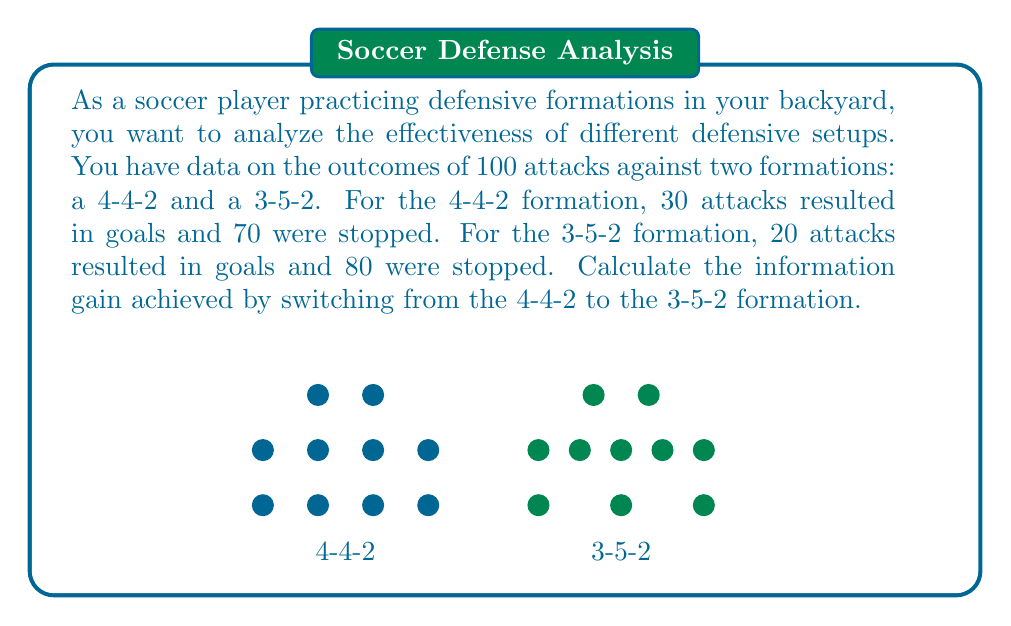Show me your answer to this math problem. To calculate the information gain, we need to compute the entropy before and after the change in formation. Let's go through this step-by-step:

1. Calculate the entropy for the 4-4-2 formation:
   Let $p(goal) = 30/100 = 0.3$ and $p(stopped) = 70/100 = 0.7$
   
   $$H(4-4-2) = -0.3 \log_2(0.3) - 0.7 \log_2(0.7)$$
   $$H(4-4-2) = 0.3 * 1.737 + 0.7 * 0.515 = 0.8821 \text{ bits}$$

2. Calculate the entropy for the 3-5-2 formation:
   Let $p(goal) = 20/100 = 0.2$ and $p(stopped) = 80/100 = 0.8$
   
   $$H(3-5-2) = -0.2 \log_2(0.2) - 0.8 \log_2(0.8)$$
   $$H(3-5-2) = 0.2 * 2.322 + 0.8 * 0.322 = 0.7219 \text{ bits}$$

3. Calculate the information gain:
   Information Gain = Entropy(before) - Entropy(after)
   $$IG = H(4-4-2) - H(3-5-2)$$
   $$IG = 0.8821 - 0.7219 = 0.1602 \text{ bits}$$

The information gain represents the reduction in uncertainty about the outcome of an attack when switching from the 4-4-2 to the 3-5-2 formation.
Answer: 0.1602 bits 